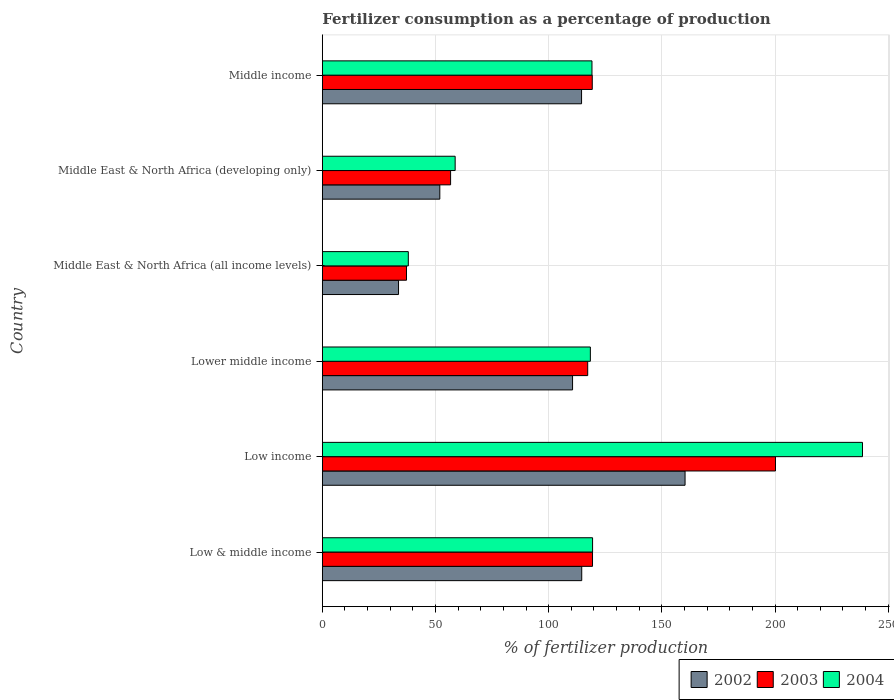How many different coloured bars are there?
Give a very brief answer. 3. Are the number of bars on each tick of the Y-axis equal?
Give a very brief answer. Yes. How many bars are there on the 1st tick from the top?
Your answer should be compact. 3. How many bars are there on the 1st tick from the bottom?
Offer a terse response. 3. What is the label of the 2nd group of bars from the top?
Your answer should be very brief. Middle East & North Africa (developing only). In how many cases, is the number of bars for a given country not equal to the number of legend labels?
Your answer should be compact. 0. What is the percentage of fertilizers consumed in 2004 in Lower middle income?
Your answer should be compact. 118.4. Across all countries, what is the maximum percentage of fertilizers consumed in 2003?
Ensure brevity in your answer.  200.18. Across all countries, what is the minimum percentage of fertilizers consumed in 2004?
Offer a very short reply. 37.99. In which country was the percentage of fertilizers consumed in 2002 maximum?
Your response must be concise. Low income. In which country was the percentage of fertilizers consumed in 2003 minimum?
Offer a terse response. Middle East & North Africa (all income levels). What is the total percentage of fertilizers consumed in 2004 in the graph?
Provide a succinct answer. 692.16. What is the difference between the percentage of fertilizers consumed in 2003 in Low income and that in Lower middle income?
Ensure brevity in your answer.  82.95. What is the difference between the percentage of fertilizers consumed in 2003 in Low & middle income and the percentage of fertilizers consumed in 2002 in Low income?
Your response must be concise. -40.88. What is the average percentage of fertilizers consumed in 2002 per country?
Give a very brief answer. 97.57. What is the difference between the percentage of fertilizers consumed in 2002 and percentage of fertilizers consumed in 2004 in Low & middle income?
Give a very brief answer. -4.79. In how many countries, is the percentage of fertilizers consumed in 2004 greater than 210 %?
Make the answer very short. 1. What is the ratio of the percentage of fertilizers consumed in 2003 in Low & middle income to that in Low income?
Ensure brevity in your answer.  0.6. Is the percentage of fertilizers consumed in 2004 in Lower middle income less than that in Middle East & North Africa (all income levels)?
Provide a succinct answer. No. Is the difference between the percentage of fertilizers consumed in 2002 in Low income and Middle East & North Africa (developing only) greater than the difference between the percentage of fertilizers consumed in 2004 in Low income and Middle East & North Africa (developing only)?
Your response must be concise. No. What is the difference between the highest and the second highest percentage of fertilizers consumed in 2003?
Your response must be concise. 80.82. What is the difference between the highest and the lowest percentage of fertilizers consumed in 2003?
Your response must be concise. 163. What does the 2nd bar from the top in Lower middle income represents?
Offer a very short reply. 2003. What does the 2nd bar from the bottom in Middle East & North Africa (developing only) represents?
Provide a short and direct response. 2003. How many bars are there?
Provide a short and direct response. 18. Are all the bars in the graph horizontal?
Keep it short and to the point. Yes. Are the values on the major ticks of X-axis written in scientific E-notation?
Make the answer very short. No. Does the graph contain any zero values?
Your response must be concise. No. Does the graph contain grids?
Ensure brevity in your answer.  Yes. Where does the legend appear in the graph?
Keep it short and to the point. Bottom right. How many legend labels are there?
Your answer should be very brief. 3. What is the title of the graph?
Offer a terse response. Fertilizer consumption as a percentage of production. What is the label or title of the X-axis?
Give a very brief answer. % of fertilizer production. What is the label or title of the Y-axis?
Your response must be concise. Country. What is the % of fertilizer production in 2002 in Low & middle income?
Keep it short and to the point. 114.59. What is the % of fertilizer production in 2003 in Low & middle income?
Offer a terse response. 119.36. What is the % of fertilizer production in 2004 in Low & middle income?
Your answer should be compact. 119.38. What is the % of fertilizer production of 2002 in Low income?
Provide a short and direct response. 160.24. What is the % of fertilizer production in 2003 in Low income?
Provide a short and direct response. 200.18. What is the % of fertilizer production in 2004 in Low income?
Offer a very short reply. 238.61. What is the % of fertilizer production in 2002 in Lower middle income?
Your answer should be very brief. 110.54. What is the % of fertilizer production of 2003 in Lower middle income?
Keep it short and to the point. 117.23. What is the % of fertilizer production in 2004 in Lower middle income?
Keep it short and to the point. 118.4. What is the % of fertilizer production of 2002 in Middle East & North Africa (all income levels)?
Keep it short and to the point. 33.66. What is the % of fertilizer production in 2003 in Middle East & North Africa (all income levels)?
Offer a terse response. 37.18. What is the % of fertilizer production in 2004 in Middle East & North Africa (all income levels)?
Your answer should be compact. 37.99. What is the % of fertilizer production in 2002 in Middle East & North Africa (developing only)?
Your answer should be compact. 51.89. What is the % of fertilizer production of 2003 in Middle East & North Africa (developing only)?
Offer a very short reply. 56.66. What is the % of fertilizer production of 2004 in Middle East & North Africa (developing only)?
Make the answer very short. 58.68. What is the % of fertilizer production in 2002 in Middle income?
Give a very brief answer. 114.51. What is the % of fertilizer production of 2003 in Middle income?
Keep it short and to the point. 119.25. What is the % of fertilizer production in 2004 in Middle income?
Provide a short and direct response. 119.11. Across all countries, what is the maximum % of fertilizer production of 2002?
Keep it short and to the point. 160.24. Across all countries, what is the maximum % of fertilizer production of 2003?
Provide a succinct answer. 200.18. Across all countries, what is the maximum % of fertilizer production in 2004?
Provide a short and direct response. 238.61. Across all countries, what is the minimum % of fertilizer production of 2002?
Provide a short and direct response. 33.66. Across all countries, what is the minimum % of fertilizer production in 2003?
Ensure brevity in your answer.  37.18. Across all countries, what is the minimum % of fertilizer production in 2004?
Offer a terse response. 37.99. What is the total % of fertilizer production of 2002 in the graph?
Provide a short and direct response. 585.44. What is the total % of fertilizer production in 2003 in the graph?
Provide a short and direct response. 649.85. What is the total % of fertilizer production in 2004 in the graph?
Your answer should be compact. 692.16. What is the difference between the % of fertilizer production in 2002 in Low & middle income and that in Low income?
Provide a short and direct response. -45.65. What is the difference between the % of fertilizer production in 2003 in Low & middle income and that in Low income?
Offer a terse response. -80.82. What is the difference between the % of fertilizer production of 2004 in Low & middle income and that in Low income?
Your answer should be very brief. -119.23. What is the difference between the % of fertilizer production of 2002 in Low & middle income and that in Lower middle income?
Provide a succinct answer. 4.06. What is the difference between the % of fertilizer production of 2003 in Low & middle income and that in Lower middle income?
Your response must be concise. 2.13. What is the difference between the % of fertilizer production in 2004 in Low & middle income and that in Lower middle income?
Provide a short and direct response. 0.98. What is the difference between the % of fertilizer production of 2002 in Low & middle income and that in Middle East & North Africa (all income levels)?
Offer a very short reply. 80.93. What is the difference between the % of fertilizer production of 2003 in Low & middle income and that in Middle East & North Africa (all income levels)?
Make the answer very short. 82.17. What is the difference between the % of fertilizer production of 2004 in Low & middle income and that in Middle East & North Africa (all income levels)?
Your answer should be compact. 81.39. What is the difference between the % of fertilizer production of 2002 in Low & middle income and that in Middle East & North Africa (developing only)?
Keep it short and to the point. 62.7. What is the difference between the % of fertilizer production in 2003 in Low & middle income and that in Middle East & North Africa (developing only)?
Your answer should be compact. 62.7. What is the difference between the % of fertilizer production in 2004 in Low & middle income and that in Middle East & North Africa (developing only)?
Ensure brevity in your answer.  60.7. What is the difference between the % of fertilizer production of 2002 in Low & middle income and that in Middle income?
Your response must be concise. 0.08. What is the difference between the % of fertilizer production in 2003 in Low & middle income and that in Middle income?
Provide a short and direct response. 0.11. What is the difference between the % of fertilizer production in 2004 in Low & middle income and that in Middle income?
Ensure brevity in your answer.  0.27. What is the difference between the % of fertilizer production of 2002 in Low income and that in Lower middle income?
Make the answer very short. 49.7. What is the difference between the % of fertilizer production of 2003 in Low income and that in Lower middle income?
Your response must be concise. 82.95. What is the difference between the % of fertilizer production in 2004 in Low income and that in Lower middle income?
Your answer should be very brief. 120.21. What is the difference between the % of fertilizer production in 2002 in Low income and that in Middle East & North Africa (all income levels)?
Give a very brief answer. 126.58. What is the difference between the % of fertilizer production of 2003 in Low income and that in Middle East & North Africa (all income levels)?
Make the answer very short. 163. What is the difference between the % of fertilizer production in 2004 in Low income and that in Middle East & North Africa (all income levels)?
Keep it short and to the point. 200.63. What is the difference between the % of fertilizer production in 2002 in Low income and that in Middle East & North Africa (developing only)?
Ensure brevity in your answer.  108.34. What is the difference between the % of fertilizer production in 2003 in Low income and that in Middle East & North Africa (developing only)?
Your response must be concise. 143.52. What is the difference between the % of fertilizer production in 2004 in Low income and that in Middle East & North Africa (developing only)?
Keep it short and to the point. 179.94. What is the difference between the % of fertilizer production of 2002 in Low income and that in Middle income?
Offer a very short reply. 45.73. What is the difference between the % of fertilizer production of 2003 in Low income and that in Middle income?
Provide a short and direct response. 80.93. What is the difference between the % of fertilizer production of 2004 in Low income and that in Middle income?
Your answer should be compact. 119.5. What is the difference between the % of fertilizer production in 2002 in Lower middle income and that in Middle East & North Africa (all income levels)?
Your response must be concise. 76.87. What is the difference between the % of fertilizer production of 2003 in Lower middle income and that in Middle East & North Africa (all income levels)?
Offer a terse response. 80.05. What is the difference between the % of fertilizer production of 2004 in Lower middle income and that in Middle East & North Africa (all income levels)?
Provide a succinct answer. 80.41. What is the difference between the % of fertilizer production in 2002 in Lower middle income and that in Middle East & North Africa (developing only)?
Offer a very short reply. 58.64. What is the difference between the % of fertilizer production of 2003 in Lower middle income and that in Middle East & North Africa (developing only)?
Your answer should be compact. 60.57. What is the difference between the % of fertilizer production in 2004 in Lower middle income and that in Middle East & North Africa (developing only)?
Offer a terse response. 59.72. What is the difference between the % of fertilizer production of 2002 in Lower middle income and that in Middle income?
Ensure brevity in your answer.  -3.98. What is the difference between the % of fertilizer production of 2003 in Lower middle income and that in Middle income?
Offer a terse response. -2.02. What is the difference between the % of fertilizer production in 2004 in Lower middle income and that in Middle income?
Offer a terse response. -0.71. What is the difference between the % of fertilizer production of 2002 in Middle East & North Africa (all income levels) and that in Middle East & North Africa (developing only)?
Provide a succinct answer. -18.23. What is the difference between the % of fertilizer production of 2003 in Middle East & North Africa (all income levels) and that in Middle East & North Africa (developing only)?
Your answer should be compact. -19.48. What is the difference between the % of fertilizer production of 2004 in Middle East & North Africa (all income levels) and that in Middle East & North Africa (developing only)?
Provide a short and direct response. -20.69. What is the difference between the % of fertilizer production of 2002 in Middle East & North Africa (all income levels) and that in Middle income?
Provide a short and direct response. -80.85. What is the difference between the % of fertilizer production of 2003 in Middle East & North Africa (all income levels) and that in Middle income?
Provide a succinct answer. -82.06. What is the difference between the % of fertilizer production of 2004 in Middle East & North Africa (all income levels) and that in Middle income?
Your response must be concise. -81.12. What is the difference between the % of fertilizer production in 2002 in Middle East & North Africa (developing only) and that in Middle income?
Keep it short and to the point. -62.62. What is the difference between the % of fertilizer production in 2003 in Middle East & North Africa (developing only) and that in Middle income?
Offer a very short reply. -62.59. What is the difference between the % of fertilizer production of 2004 in Middle East & North Africa (developing only) and that in Middle income?
Your response must be concise. -60.43. What is the difference between the % of fertilizer production of 2002 in Low & middle income and the % of fertilizer production of 2003 in Low income?
Offer a terse response. -85.58. What is the difference between the % of fertilizer production of 2002 in Low & middle income and the % of fertilizer production of 2004 in Low income?
Your response must be concise. -124.02. What is the difference between the % of fertilizer production in 2003 in Low & middle income and the % of fertilizer production in 2004 in Low income?
Keep it short and to the point. -119.26. What is the difference between the % of fertilizer production in 2002 in Low & middle income and the % of fertilizer production in 2003 in Lower middle income?
Your answer should be very brief. -2.64. What is the difference between the % of fertilizer production in 2002 in Low & middle income and the % of fertilizer production in 2004 in Lower middle income?
Offer a very short reply. -3.81. What is the difference between the % of fertilizer production in 2003 in Low & middle income and the % of fertilizer production in 2004 in Lower middle income?
Your response must be concise. 0.96. What is the difference between the % of fertilizer production in 2002 in Low & middle income and the % of fertilizer production in 2003 in Middle East & North Africa (all income levels)?
Provide a succinct answer. 77.41. What is the difference between the % of fertilizer production of 2002 in Low & middle income and the % of fertilizer production of 2004 in Middle East & North Africa (all income levels)?
Your answer should be compact. 76.61. What is the difference between the % of fertilizer production of 2003 in Low & middle income and the % of fertilizer production of 2004 in Middle East & North Africa (all income levels)?
Offer a terse response. 81.37. What is the difference between the % of fertilizer production of 2002 in Low & middle income and the % of fertilizer production of 2003 in Middle East & North Africa (developing only)?
Your response must be concise. 57.94. What is the difference between the % of fertilizer production in 2002 in Low & middle income and the % of fertilizer production in 2004 in Middle East & North Africa (developing only)?
Ensure brevity in your answer.  55.92. What is the difference between the % of fertilizer production of 2003 in Low & middle income and the % of fertilizer production of 2004 in Middle East & North Africa (developing only)?
Ensure brevity in your answer.  60.68. What is the difference between the % of fertilizer production in 2002 in Low & middle income and the % of fertilizer production in 2003 in Middle income?
Provide a short and direct response. -4.65. What is the difference between the % of fertilizer production in 2002 in Low & middle income and the % of fertilizer production in 2004 in Middle income?
Your answer should be very brief. -4.52. What is the difference between the % of fertilizer production in 2003 in Low & middle income and the % of fertilizer production in 2004 in Middle income?
Your response must be concise. 0.25. What is the difference between the % of fertilizer production in 2002 in Low income and the % of fertilizer production in 2003 in Lower middle income?
Provide a succinct answer. 43.01. What is the difference between the % of fertilizer production in 2002 in Low income and the % of fertilizer production in 2004 in Lower middle income?
Make the answer very short. 41.84. What is the difference between the % of fertilizer production of 2003 in Low income and the % of fertilizer production of 2004 in Lower middle income?
Offer a very short reply. 81.78. What is the difference between the % of fertilizer production in 2002 in Low income and the % of fertilizer production in 2003 in Middle East & North Africa (all income levels)?
Offer a very short reply. 123.06. What is the difference between the % of fertilizer production in 2002 in Low income and the % of fertilizer production in 2004 in Middle East & North Africa (all income levels)?
Your answer should be very brief. 122.25. What is the difference between the % of fertilizer production of 2003 in Low income and the % of fertilizer production of 2004 in Middle East & North Africa (all income levels)?
Ensure brevity in your answer.  162.19. What is the difference between the % of fertilizer production of 2002 in Low income and the % of fertilizer production of 2003 in Middle East & North Africa (developing only)?
Ensure brevity in your answer.  103.58. What is the difference between the % of fertilizer production of 2002 in Low income and the % of fertilizer production of 2004 in Middle East & North Africa (developing only)?
Your response must be concise. 101.56. What is the difference between the % of fertilizer production of 2003 in Low income and the % of fertilizer production of 2004 in Middle East & North Africa (developing only)?
Keep it short and to the point. 141.5. What is the difference between the % of fertilizer production in 2002 in Low income and the % of fertilizer production in 2003 in Middle income?
Provide a short and direct response. 40.99. What is the difference between the % of fertilizer production in 2002 in Low income and the % of fertilizer production in 2004 in Middle income?
Provide a short and direct response. 41.13. What is the difference between the % of fertilizer production in 2003 in Low income and the % of fertilizer production in 2004 in Middle income?
Your response must be concise. 81.07. What is the difference between the % of fertilizer production of 2002 in Lower middle income and the % of fertilizer production of 2003 in Middle East & North Africa (all income levels)?
Your answer should be compact. 73.36. What is the difference between the % of fertilizer production in 2002 in Lower middle income and the % of fertilizer production in 2004 in Middle East & North Africa (all income levels)?
Make the answer very short. 72.55. What is the difference between the % of fertilizer production in 2003 in Lower middle income and the % of fertilizer production in 2004 in Middle East & North Africa (all income levels)?
Keep it short and to the point. 79.24. What is the difference between the % of fertilizer production in 2002 in Lower middle income and the % of fertilizer production in 2003 in Middle East & North Africa (developing only)?
Your response must be concise. 53.88. What is the difference between the % of fertilizer production in 2002 in Lower middle income and the % of fertilizer production in 2004 in Middle East & North Africa (developing only)?
Make the answer very short. 51.86. What is the difference between the % of fertilizer production of 2003 in Lower middle income and the % of fertilizer production of 2004 in Middle East & North Africa (developing only)?
Make the answer very short. 58.55. What is the difference between the % of fertilizer production in 2002 in Lower middle income and the % of fertilizer production in 2003 in Middle income?
Offer a terse response. -8.71. What is the difference between the % of fertilizer production of 2002 in Lower middle income and the % of fertilizer production of 2004 in Middle income?
Keep it short and to the point. -8.57. What is the difference between the % of fertilizer production in 2003 in Lower middle income and the % of fertilizer production in 2004 in Middle income?
Provide a short and direct response. -1.88. What is the difference between the % of fertilizer production of 2002 in Middle East & North Africa (all income levels) and the % of fertilizer production of 2003 in Middle East & North Africa (developing only)?
Your answer should be compact. -23. What is the difference between the % of fertilizer production in 2002 in Middle East & North Africa (all income levels) and the % of fertilizer production in 2004 in Middle East & North Africa (developing only)?
Provide a short and direct response. -25.01. What is the difference between the % of fertilizer production of 2003 in Middle East & North Africa (all income levels) and the % of fertilizer production of 2004 in Middle East & North Africa (developing only)?
Offer a terse response. -21.49. What is the difference between the % of fertilizer production of 2002 in Middle East & North Africa (all income levels) and the % of fertilizer production of 2003 in Middle income?
Your answer should be very brief. -85.58. What is the difference between the % of fertilizer production in 2002 in Middle East & North Africa (all income levels) and the % of fertilizer production in 2004 in Middle income?
Give a very brief answer. -85.45. What is the difference between the % of fertilizer production in 2003 in Middle East & North Africa (all income levels) and the % of fertilizer production in 2004 in Middle income?
Your answer should be very brief. -81.93. What is the difference between the % of fertilizer production of 2002 in Middle East & North Africa (developing only) and the % of fertilizer production of 2003 in Middle income?
Your response must be concise. -67.35. What is the difference between the % of fertilizer production of 2002 in Middle East & North Africa (developing only) and the % of fertilizer production of 2004 in Middle income?
Give a very brief answer. -67.21. What is the difference between the % of fertilizer production of 2003 in Middle East & North Africa (developing only) and the % of fertilizer production of 2004 in Middle income?
Ensure brevity in your answer.  -62.45. What is the average % of fertilizer production of 2002 per country?
Provide a short and direct response. 97.57. What is the average % of fertilizer production of 2003 per country?
Give a very brief answer. 108.31. What is the average % of fertilizer production in 2004 per country?
Your answer should be very brief. 115.36. What is the difference between the % of fertilizer production in 2002 and % of fertilizer production in 2003 in Low & middle income?
Offer a terse response. -4.76. What is the difference between the % of fertilizer production in 2002 and % of fertilizer production in 2004 in Low & middle income?
Keep it short and to the point. -4.79. What is the difference between the % of fertilizer production of 2003 and % of fertilizer production of 2004 in Low & middle income?
Provide a short and direct response. -0.02. What is the difference between the % of fertilizer production of 2002 and % of fertilizer production of 2003 in Low income?
Offer a terse response. -39.94. What is the difference between the % of fertilizer production in 2002 and % of fertilizer production in 2004 in Low income?
Your response must be concise. -78.37. What is the difference between the % of fertilizer production of 2003 and % of fertilizer production of 2004 in Low income?
Keep it short and to the point. -38.43. What is the difference between the % of fertilizer production of 2002 and % of fertilizer production of 2003 in Lower middle income?
Provide a succinct answer. -6.69. What is the difference between the % of fertilizer production of 2002 and % of fertilizer production of 2004 in Lower middle income?
Your answer should be compact. -7.86. What is the difference between the % of fertilizer production of 2003 and % of fertilizer production of 2004 in Lower middle income?
Offer a very short reply. -1.17. What is the difference between the % of fertilizer production of 2002 and % of fertilizer production of 2003 in Middle East & North Africa (all income levels)?
Make the answer very short. -3.52. What is the difference between the % of fertilizer production of 2002 and % of fertilizer production of 2004 in Middle East & North Africa (all income levels)?
Your answer should be very brief. -4.32. What is the difference between the % of fertilizer production of 2003 and % of fertilizer production of 2004 in Middle East & North Africa (all income levels)?
Your answer should be compact. -0.81. What is the difference between the % of fertilizer production in 2002 and % of fertilizer production in 2003 in Middle East & North Africa (developing only)?
Your response must be concise. -4.76. What is the difference between the % of fertilizer production of 2002 and % of fertilizer production of 2004 in Middle East & North Africa (developing only)?
Provide a short and direct response. -6.78. What is the difference between the % of fertilizer production of 2003 and % of fertilizer production of 2004 in Middle East & North Africa (developing only)?
Provide a short and direct response. -2.02. What is the difference between the % of fertilizer production of 2002 and % of fertilizer production of 2003 in Middle income?
Your answer should be very brief. -4.73. What is the difference between the % of fertilizer production of 2002 and % of fertilizer production of 2004 in Middle income?
Your response must be concise. -4.59. What is the difference between the % of fertilizer production in 2003 and % of fertilizer production in 2004 in Middle income?
Ensure brevity in your answer.  0.14. What is the ratio of the % of fertilizer production of 2002 in Low & middle income to that in Low income?
Give a very brief answer. 0.72. What is the ratio of the % of fertilizer production in 2003 in Low & middle income to that in Low income?
Give a very brief answer. 0.6. What is the ratio of the % of fertilizer production in 2004 in Low & middle income to that in Low income?
Provide a short and direct response. 0.5. What is the ratio of the % of fertilizer production in 2002 in Low & middle income to that in Lower middle income?
Your answer should be compact. 1.04. What is the ratio of the % of fertilizer production in 2003 in Low & middle income to that in Lower middle income?
Provide a short and direct response. 1.02. What is the ratio of the % of fertilizer production in 2004 in Low & middle income to that in Lower middle income?
Provide a succinct answer. 1.01. What is the ratio of the % of fertilizer production in 2002 in Low & middle income to that in Middle East & North Africa (all income levels)?
Offer a terse response. 3.4. What is the ratio of the % of fertilizer production of 2003 in Low & middle income to that in Middle East & North Africa (all income levels)?
Offer a very short reply. 3.21. What is the ratio of the % of fertilizer production of 2004 in Low & middle income to that in Middle East & North Africa (all income levels)?
Give a very brief answer. 3.14. What is the ratio of the % of fertilizer production of 2002 in Low & middle income to that in Middle East & North Africa (developing only)?
Offer a terse response. 2.21. What is the ratio of the % of fertilizer production in 2003 in Low & middle income to that in Middle East & North Africa (developing only)?
Give a very brief answer. 2.11. What is the ratio of the % of fertilizer production in 2004 in Low & middle income to that in Middle East & North Africa (developing only)?
Keep it short and to the point. 2.03. What is the ratio of the % of fertilizer production of 2004 in Low & middle income to that in Middle income?
Your response must be concise. 1. What is the ratio of the % of fertilizer production of 2002 in Low income to that in Lower middle income?
Make the answer very short. 1.45. What is the ratio of the % of fertilizer production of 2003 in Low income to that in Lower middle income?
Your response must be concise. 1.71. What is the ratio of the % of fertilizer production in 2004 in Low income to that in Lower middle income?
Make the answer very short. 2.02. What is the ratio of the % of fertilizer production in 2002 in Low income to that in Middle East & North Africa (all income levels)?
Give a very brief answer. 4.76. What is the ratio of the % of fertilizer production in 2003 in Low income to that in Middle East & North Africa (all income levels)?
Keep it short and to the point. 5.38. What is the ratio of the % of fertilizer production in 2004 in Low income to that in Middle East & North Africa (all income levels)?
Keep it short and to the point. 6.28. What is the ratio of the % of fertilizer production in 2002 in Low income to that in Middle East & North Africa (developing only)?
Provide a short and direct response. 3.09. What is the ratio of the % of fertilizer production in 2003 in Low income to that in Middle East & North Africa (developing only)?
Make the answer very short. 3.53. What is the ratio of the % of fertilizer production of 2004 in Low income to that in Middle East & North Africa (developing only)?
Make the answer very short. 4.07. What is the ratio of the % of fertilizer production of 2002 in Low income to that in Middle income?
Provide a succinct answer. 1.4. What is the ratio of the % of fertilizer production of 2003 in Low income to that in Middle income?
Offer a terse response. 1.68. What is the ratio of the % of fertilizer production of 2004 in Low income to that in Middle income?
Offer a terse response. 2. What is the ratio of the % of fertilizer production of 2002 in Lower middle income to that in Middle East & North Africa (all income levels)?
Ensure brevity in your answer.  3.28. What is the ratio of the % of fertilizer production of 2003 in Lower middle income to that in Middle East & North Africa (all income levels)?
Provide a short and direct response. 3.15. What is the ratio of the % of fertilizer production in 2004 in Lower middle income to that in Middle East & North Africa (all income levels)?
Ensure brevity in your answer.  3.12. What is the ratio of the % of fertilizer production of 2002 in Lower middle income to that in Middle East & North Africa (developing only)?
Give a very brief answer. 2.13. What is the ratio of the % of fertilizer production in 2003 in Lower middle income to that in Middle East & North Africa (developing only)?
Your response must be concise. 2.07. What is the ratio of the % of fertilizer production in 2004 in Lower middle income to that in Middle East & North Africa (developing only)?
Give a very brief answer. 2.02. What is the ratio of the % of fertilizer production in 2002 in Lower middle income to that in Middle income?
Ensure brevity in your answer.  0.97. What is the ratio of the % of fertilizer production of 2003 in Lower middle income to that in Middle income?
Your response must be concise. 0.98. What is the ratio of the % of fertilizer production of 2004 in Lower middle income to that in Middle income?
Provide a succinct answer. 0.99. What is the ratio of the % of fertilizer production of 2002 in Middle East & North Africa (all income levels) to that in Middle East & North Africa (developing only)?
Your answer should be compact. 0.65. What is the ratio of the % of fertilizer production of 2003 in Middle East & North Africa (all income levels) to that in Middle East & North Africa (developing only)?
Provide a short and direct response. 0.66. What is the ratio of the % of fertilizer production in 2004 in Middle East & North Africa (all income levels) to that in Middle East & North Africa (developing only)?
Your answer should be compact. 0.65. What is the ratio of the % of fertilizer production in 2002 in Middle East & North Africa (all income levels) to that in Middle income?
Ensure brevity in your answer.  0.29. What is the ratio of the % of fertilizer production in 2003 in Middle East & North Africa (all income levels) to that in Middle income?
Offer a very short reply. 0.31. What is the ratio of the % of fertilizer production of 2004 in Middle East & North Africa (all income levels) to that in Middle income?
Ensure brevity in your answer.  0.32. What is the ratio of the % of fertilizer production in 2002 in Middle East & North Africa (developing only) to that in Middle income?
Give a very brief answer. 0.45. What is the ratio of the % of fertilizer production in 2003 in Middle East & North Africa (developing only) to that in Middle income?
Provide a short and direct response. 0.48. What is the ratio of the % of fertilizer production of 2004 in Middle East & North Africa (developing only) to that in Middle income?
Provide a succinct answer. 0.49. What is the difference between the highest and the second highest % of fertilizer production of 2002?
Your response must be concise. 45.65. What is the difference between the highest and the second highest % of fertilizer production of 2003?
Your answer should be compact. 80.82. What is the difference between the highest and the second highest % of fertilizer production in 2004?
Keep it short and to the point. 119.23. What is the difference between the highest and the lowest % of fertilizer production in 2002?
Your answer should be very brief. 126.58. What is the difference between the highest and the lowest % of fertilizer production in 2003?
Give a very brief answer. 163. What is the difference between the highest and the lowest % of fertilizer production of 2004?
Your response must be concise. 200.63. 